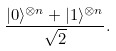<formula> <loc_0><loc_0><loc_500><loc_500>\frac { | 0 \rangle ^ { \otimes n } + | 1 \rangle ^ { \otimes n } } { \sqrt { 2 } } .</formula> 